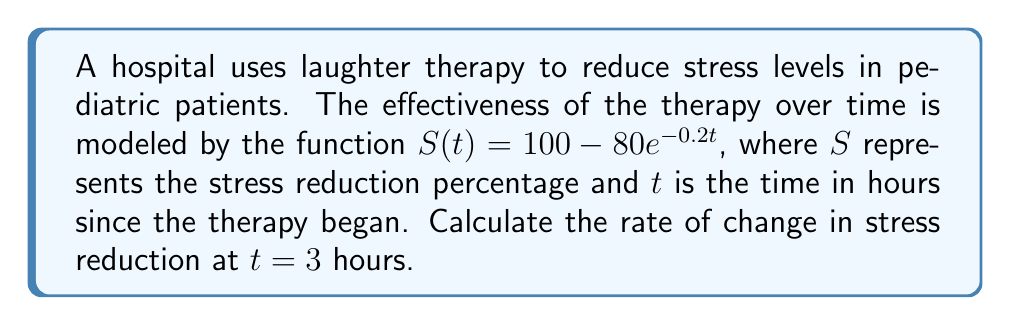Solve this math problem. To find the rate of change in stress reduction at $t = 3$ hours, we need to calculate the derivative of $S(t)$ and then evaluate it at $t = 3$.

Step 1: Find the derivative of $S(t)$
$$S(t) = 100 - 80e^{-0.2t}$$
$$\frac{d}{dt}[S(t)] = \frac{d}{dt}[100] - \frac{d}{dt}[80e^{-0.2t}]$$
$$S'(t) = 0 - 80 \cdot \frac{d}{dt}[e^{-0.2t}]$$
Using the chain rule:
$$S'(t) = 0 - 80 \cdot (-0.2) \cdot e^{-0.2t}$$
$$S'(t) = 16e^{-0.2t}$$

Step 2: Evaluate $S'(t)$ at $t = 3$
$$S'(3) = 16e^{-0.2(3)}$$
$$S'(3) = 16e^{-0.6}$$
$$S'(3) = 16 \cdot 0.5488 \approx 8.7808$$

Therefore, the rate of change in stress reduction at $t = 3$ hours is approximately 8.7808% per hour.
Answer: $16e^{-0.6}$ % per hour 